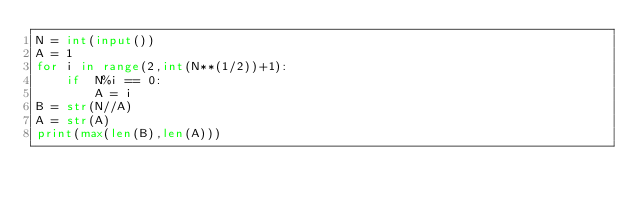<code> <loc_0><loc_0><loc_500><loc_500><_Python_>N = int(input())
A = 1
for i in range(2,int(N**(1/2))+1):
    if  N%i == 0:
        A = i
B = str(N//A)
A = str(A)
print(max(len(B),len(A)))</code> 